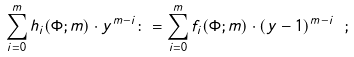<formula> <loc_0><loc_0><loc_500><loc_500>\sum _ { i = 0 } ^ { m } h _ { i } ( \Phi ; m ) \cdot y ^ { m - i } \colon = \sum _ { i = 0 } ^ { m } f _ { i } ( \Phi ; m ) \cdot ( y - 1 ) ^ { m - i } \ ;</formula> 